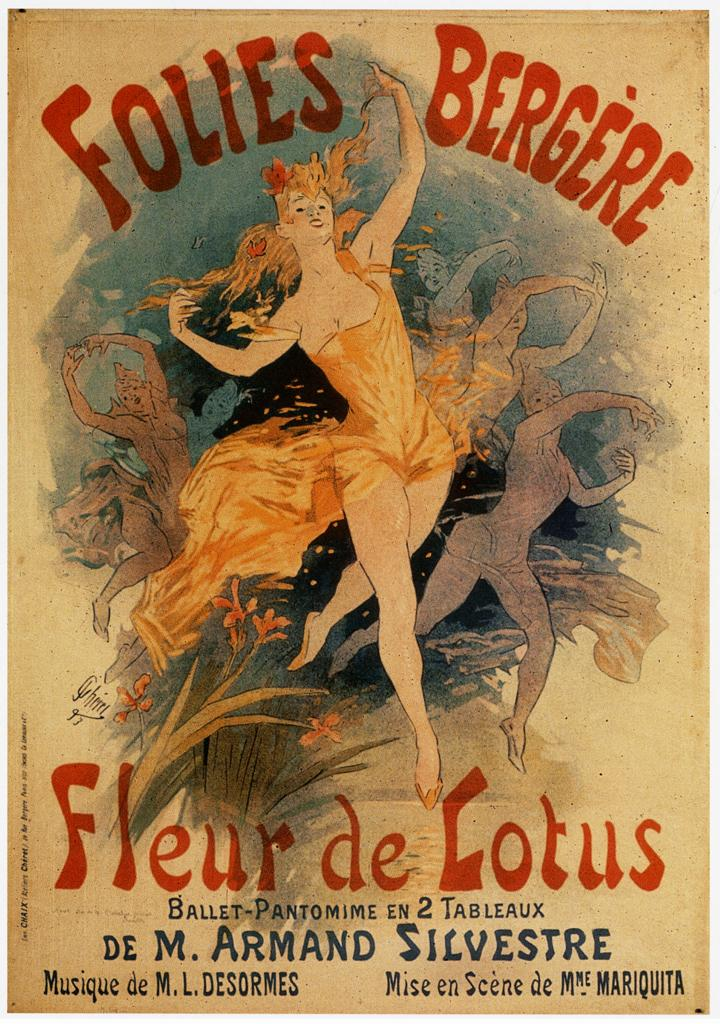Provide a one-sentence caption for the provided image. A poster advertising the Folies Bergere Fleur de Lotus. 